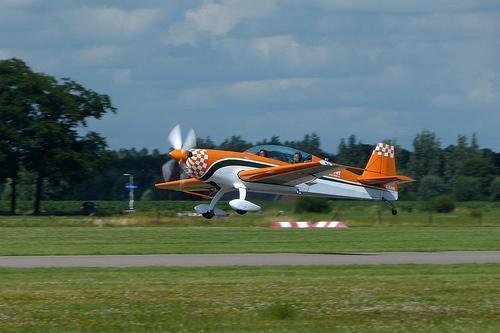How many people are in the plane?
Give a very brief answer. 2. How many of the plane's wheels are on the ground?
Give a very brief answer. 0. 